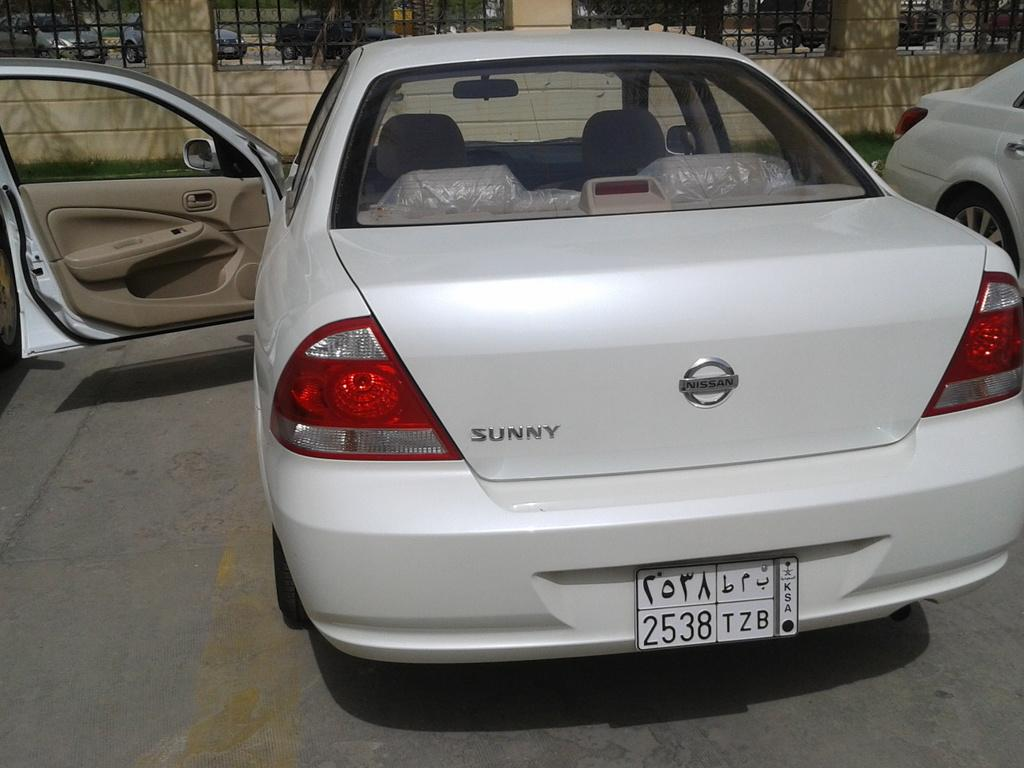What is the main subject of the image? The main subject of the image is a car with a number plate. What is the state of the car's door? The car's door is opened. What can be seen in the background of the image? There is a wall with railings in the background. Are there any other vehicles in the image? Yes, there is another car on the right side of the image. What type of club is being promoted in the image? There is no club or promotion present in the image; it features a car with an opened door and another car in the background. What is the profit margin of the car manufacturer in the image? There is no information about profit margins or car manufacturers in the image. 